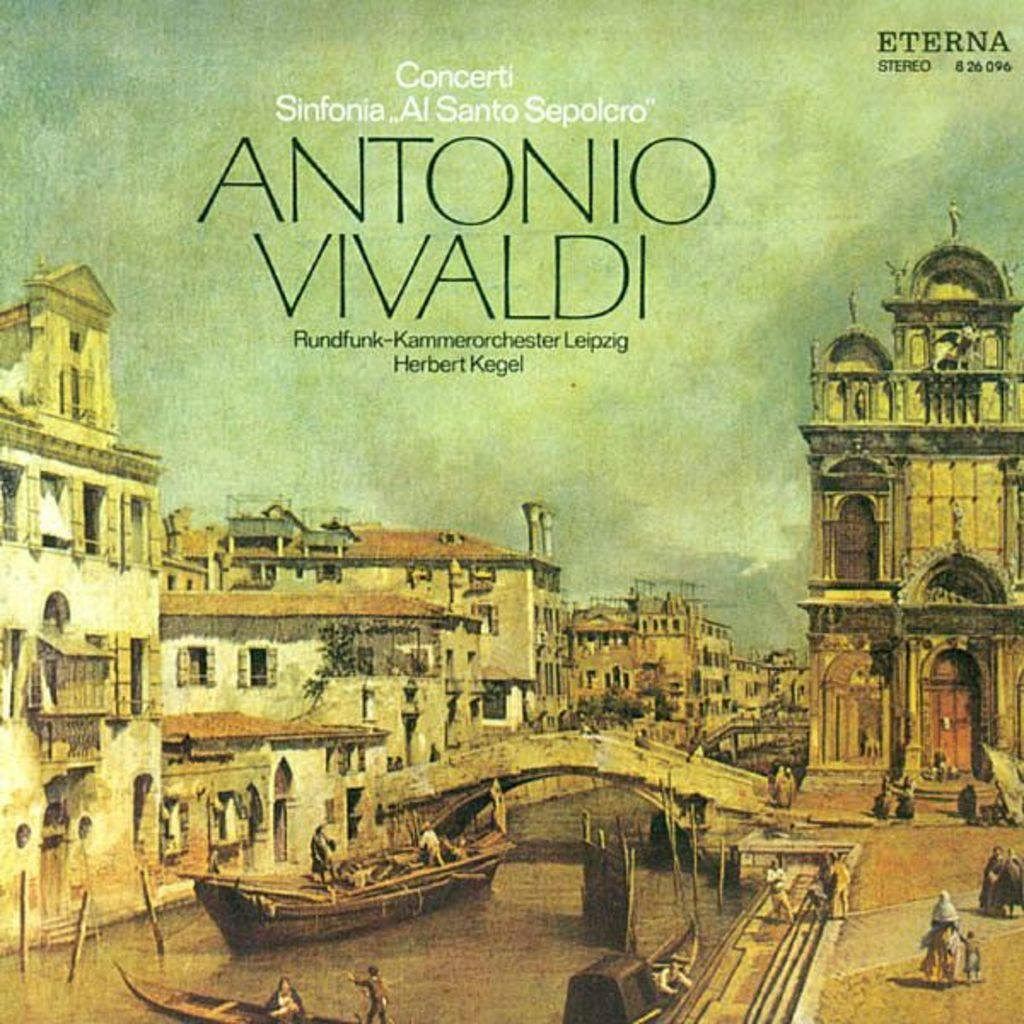<image>
Summarize the visual content of the image. An Antonia Vivaldi work features a picture of Venice on the cover. 